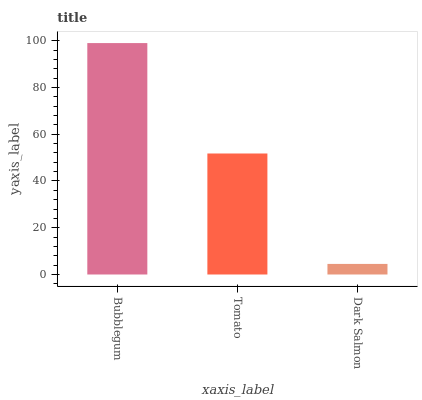Is Dark Salmon the minimum?
Answer yes or no. Yes. Is Bubblegum the maximum?
Answer yes or no. Yes. Is Tomato the minimum?
Answer yes or no. No. Is Tomato the maximum?
Answer yes or no. No. Is Bubblegum greater than Tomato?
Answer yes or no. Yes. Is Tomato less than Bubblegum?
Answer yes or no. Yes. Is Tomato greater than Bubblegum?
Answer yes or no. No. Is Bubblegum less than Tomato?
Answer yes or no. No. Is Tomato the high median?
Answer yes or no. Yes. Is Tomato the low median?
Answer yes or no. Yes. Is Dark Salmon the high median?
Answer yes or no. No. Is Bubblegum the low median?
Answer yes or no. No. 